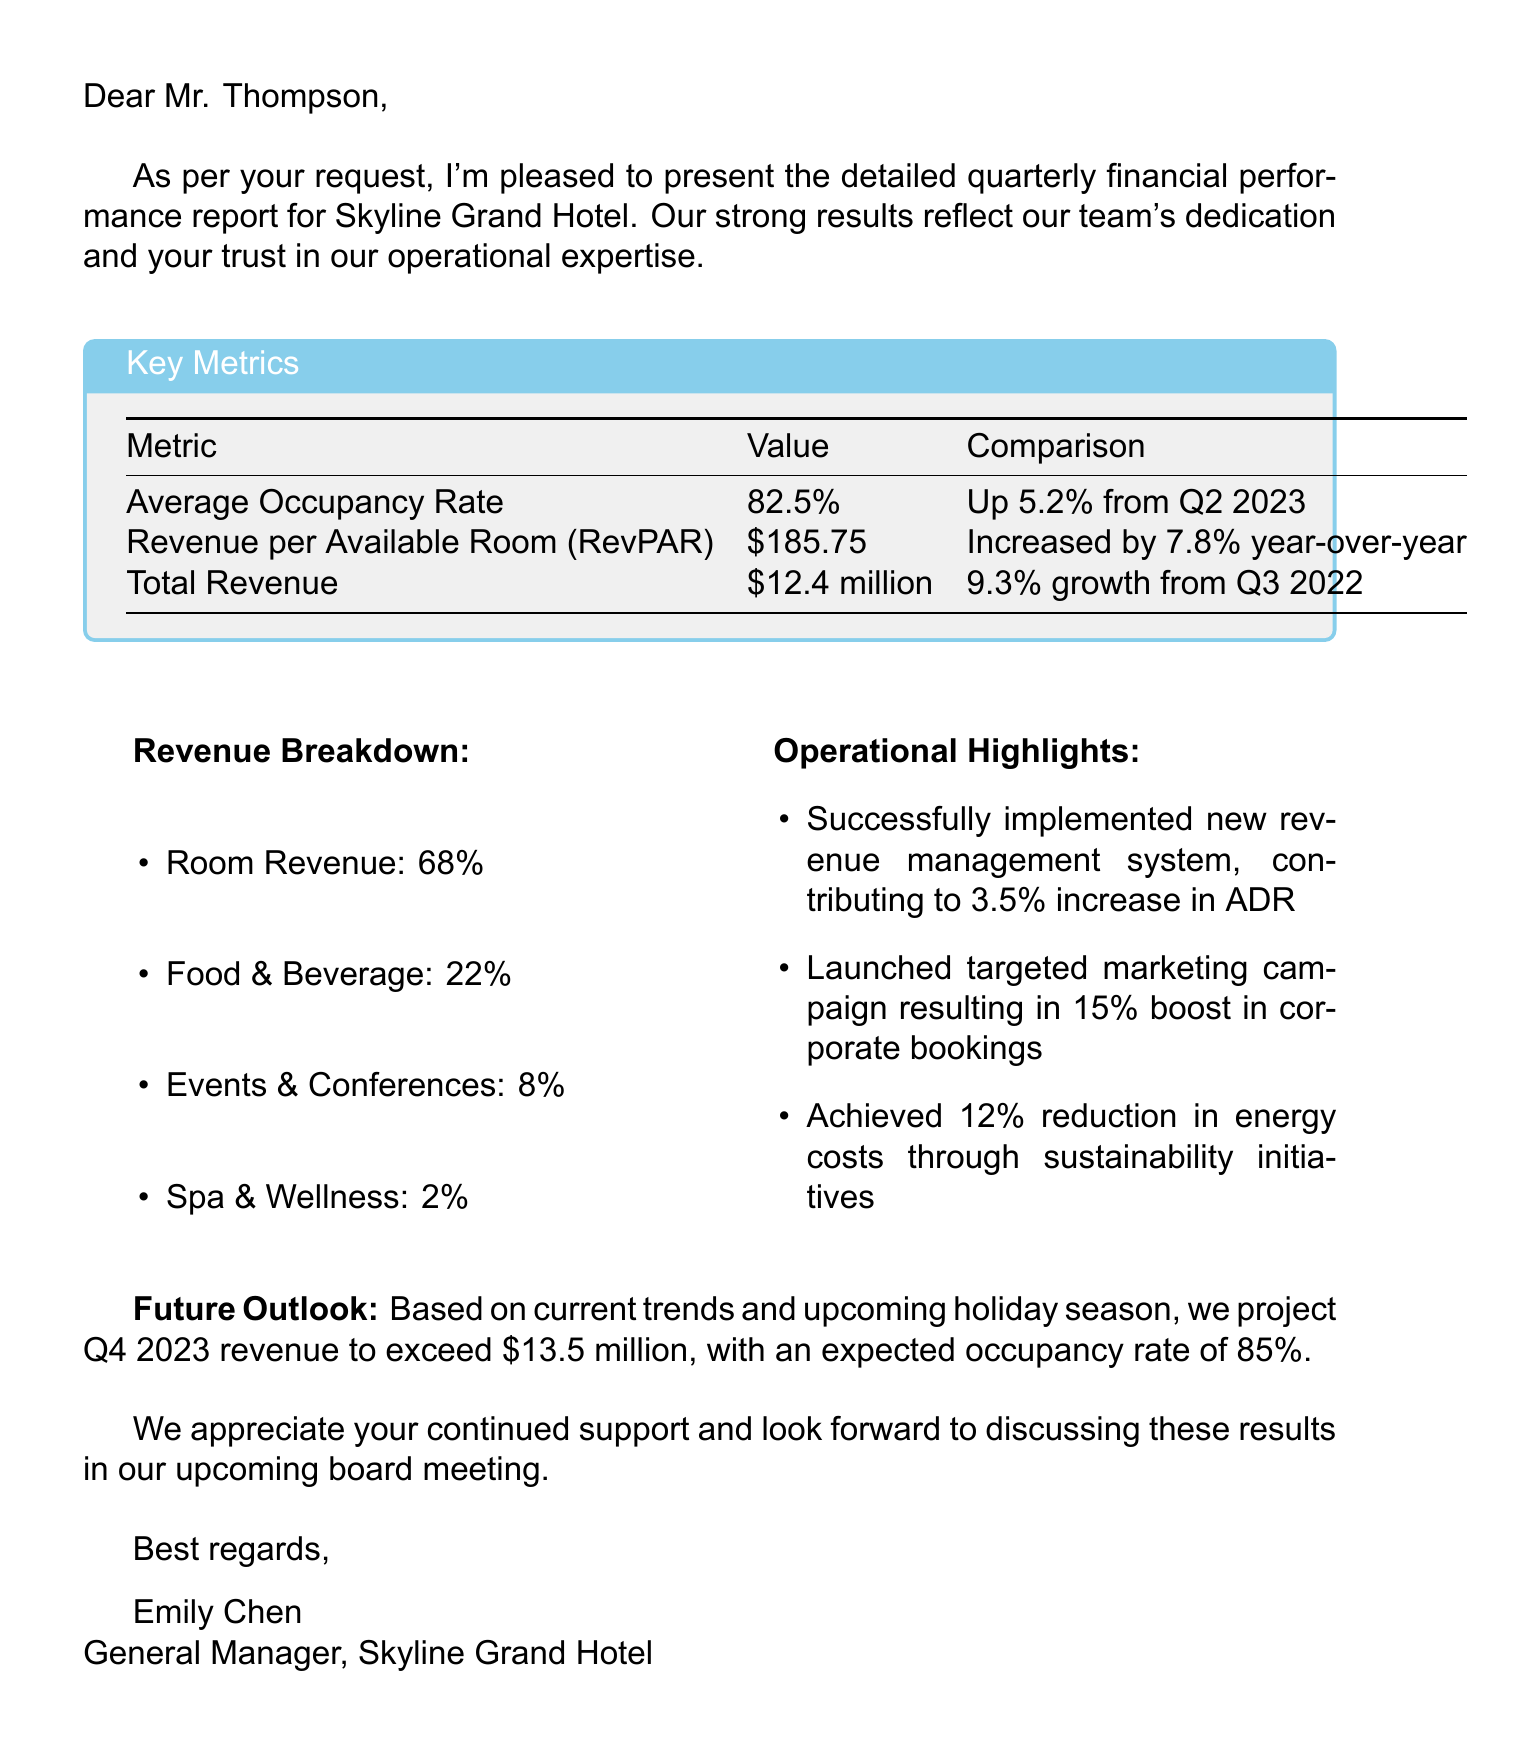What is the average occupancy rate? The average occupancy rate is explicitly mentioned in the key metrics section of the document.
Answer: 82.5% What was the revenue per available room (RevPAR) in Q3 2023? The revenue per available room is listed in the key metrics section of the document.
Answer: $185.75 How much total revenue did the hotel generate in Q3 2023? The total revenue figure is provided in the key metrics section of the document.
Answer: $12.4 million What percentage of revenue came from Room Revenue? The document provides a breakdown of revenue sources, stating the percentage from Room Revenue.
Answer: 68% What is the projected total revenue for Q4 2023? The future outlook section offers a projection for the upcoming quarter's revenue.
Answer: Over $13.5 million How much did the new revenue management system contribute to the ADR increase? This information is detailed in the operational highlights, explaining the effect of the system on ADR.
Answer: 3.5% What percentage increase in corporate bookings resulted from the targeted marketing campaign? The operational highlights mention the percentage increase due to the campaign.
Answer: 15% What is the expected occupancy rate for Q4 2023? The future outlook specifies an expected occupancy rate for the upcoming quarter.
Answer: 85% Who is the General Manager of Skyline Grand Hotel? The closing of the document identifies the individual responsible for the hotel's management.
Answer: Emily Chen 